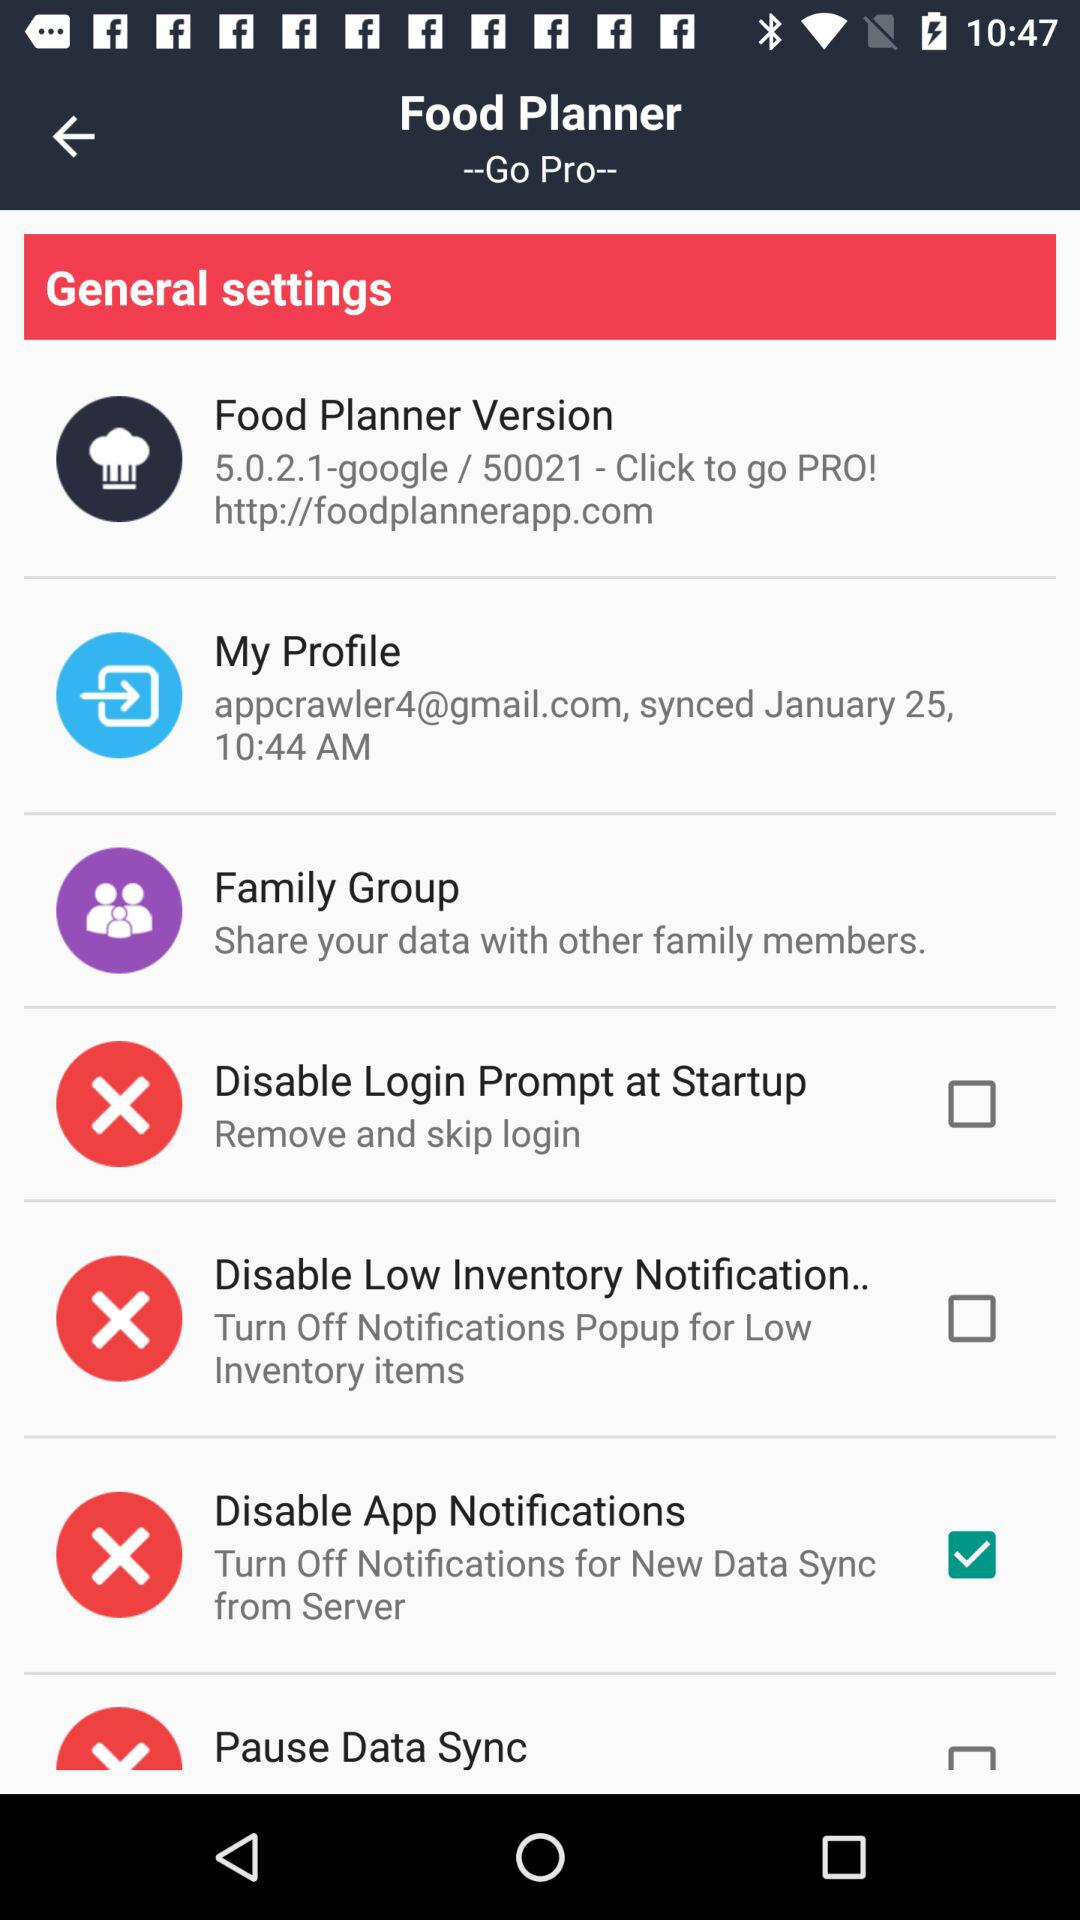What is the version of the application? The version of the application is 5.0.2.1. 